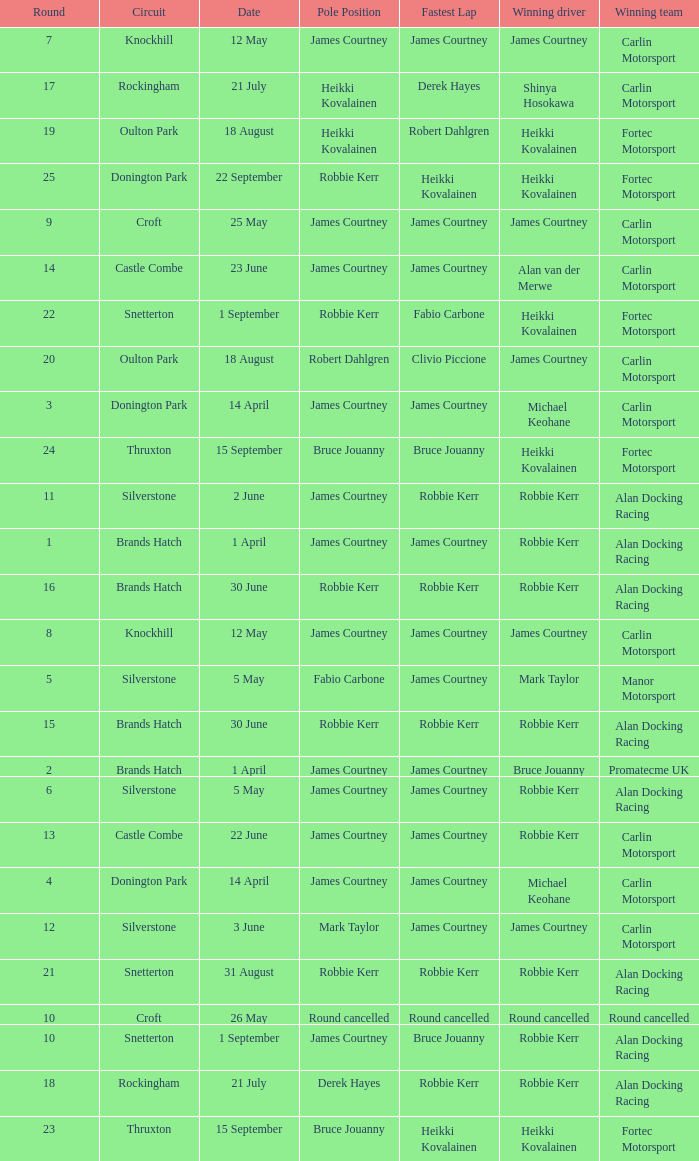What is every date of Mark Taylor as winning driver? 5 May. 